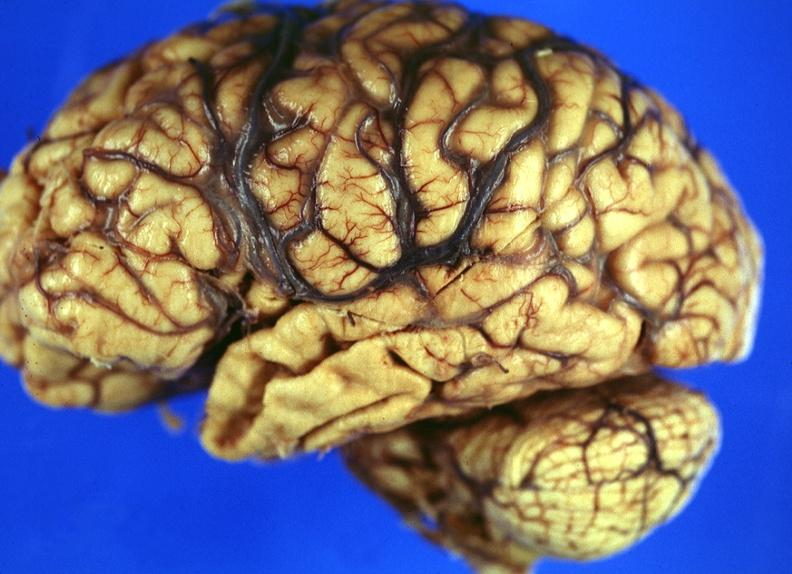does this image show brain, frontal lobe atrophy, pick 's disease?
Answer the question using a single word or phrase. Yes 